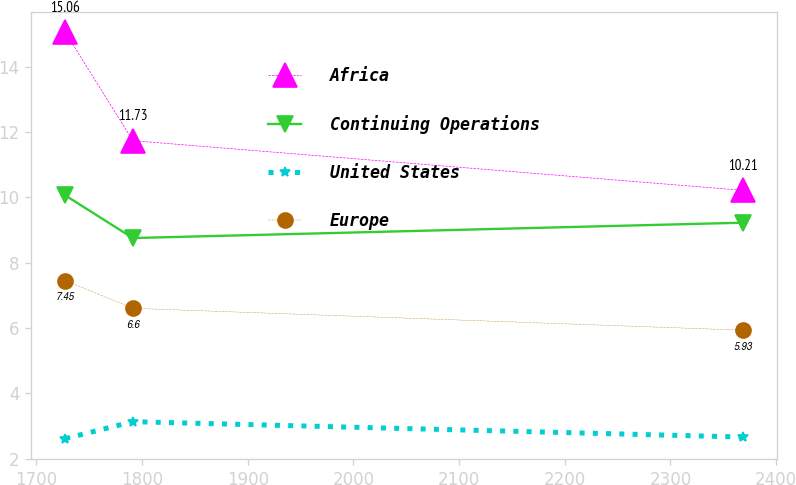<chart> <loc_0><loc_0><loc_500><loc_500><line_chart><ecel><fcel>Africa<fcel>Continuing Operations<fcel>United States<fcel>Europe<nl><fcel>1727.08<fcel>15.06<fcel>10.06<fcel>2.61<fcel>7.45<nl><fcel>1791.22<fcel>11.73<fcel>8.75<fcel>3.13<fcel>6.6<nl><fcel>2368.47<fcel>10.21<fcel>9.22<fcel>2.66<fcel>5.93<nl></chart> 